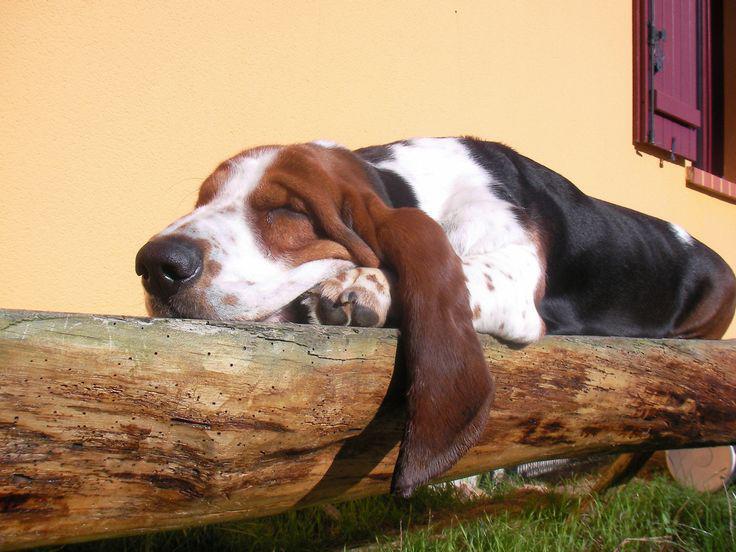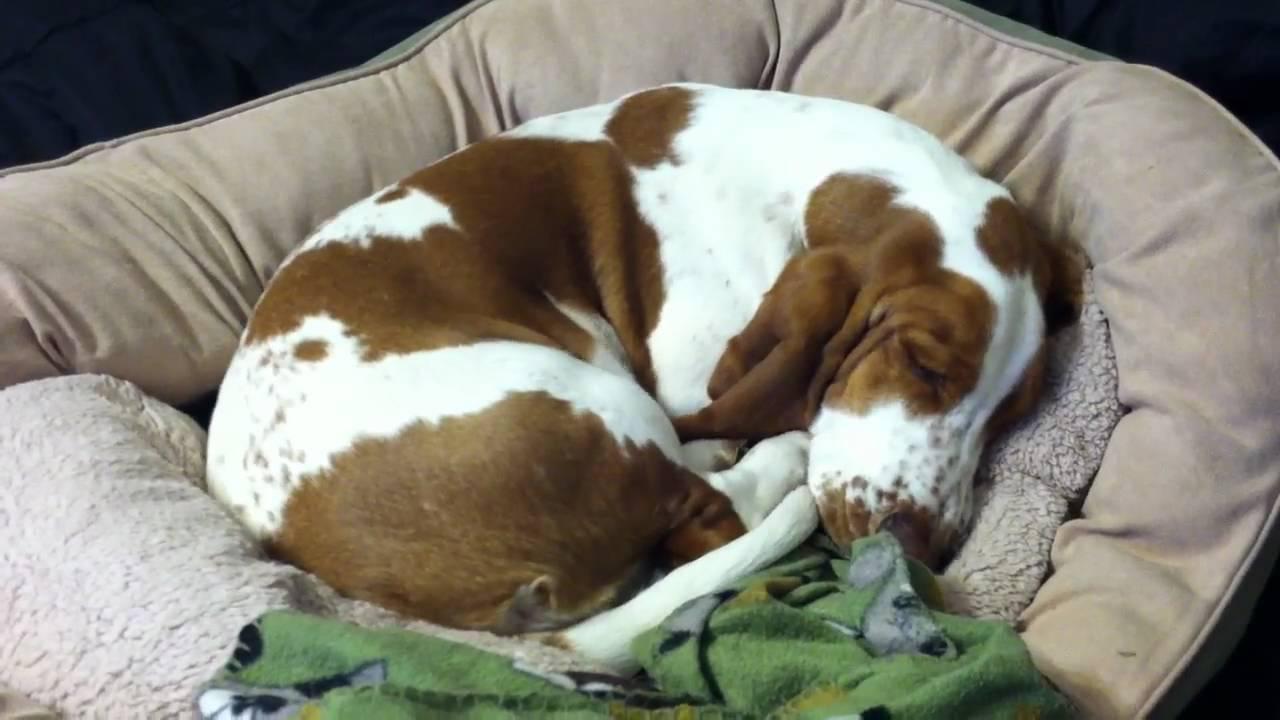The first image is the image on the left, the second image is the image on the right. For the images shown, is this caption "One of the images has a dog laying on a log." true? Answer yes or no. Yes. The first image is the image on the left, the second image is the image on the right. Assess this claim about the two images: "One dog has its eyes open.". Correct or not? Answer yes or no. No. 